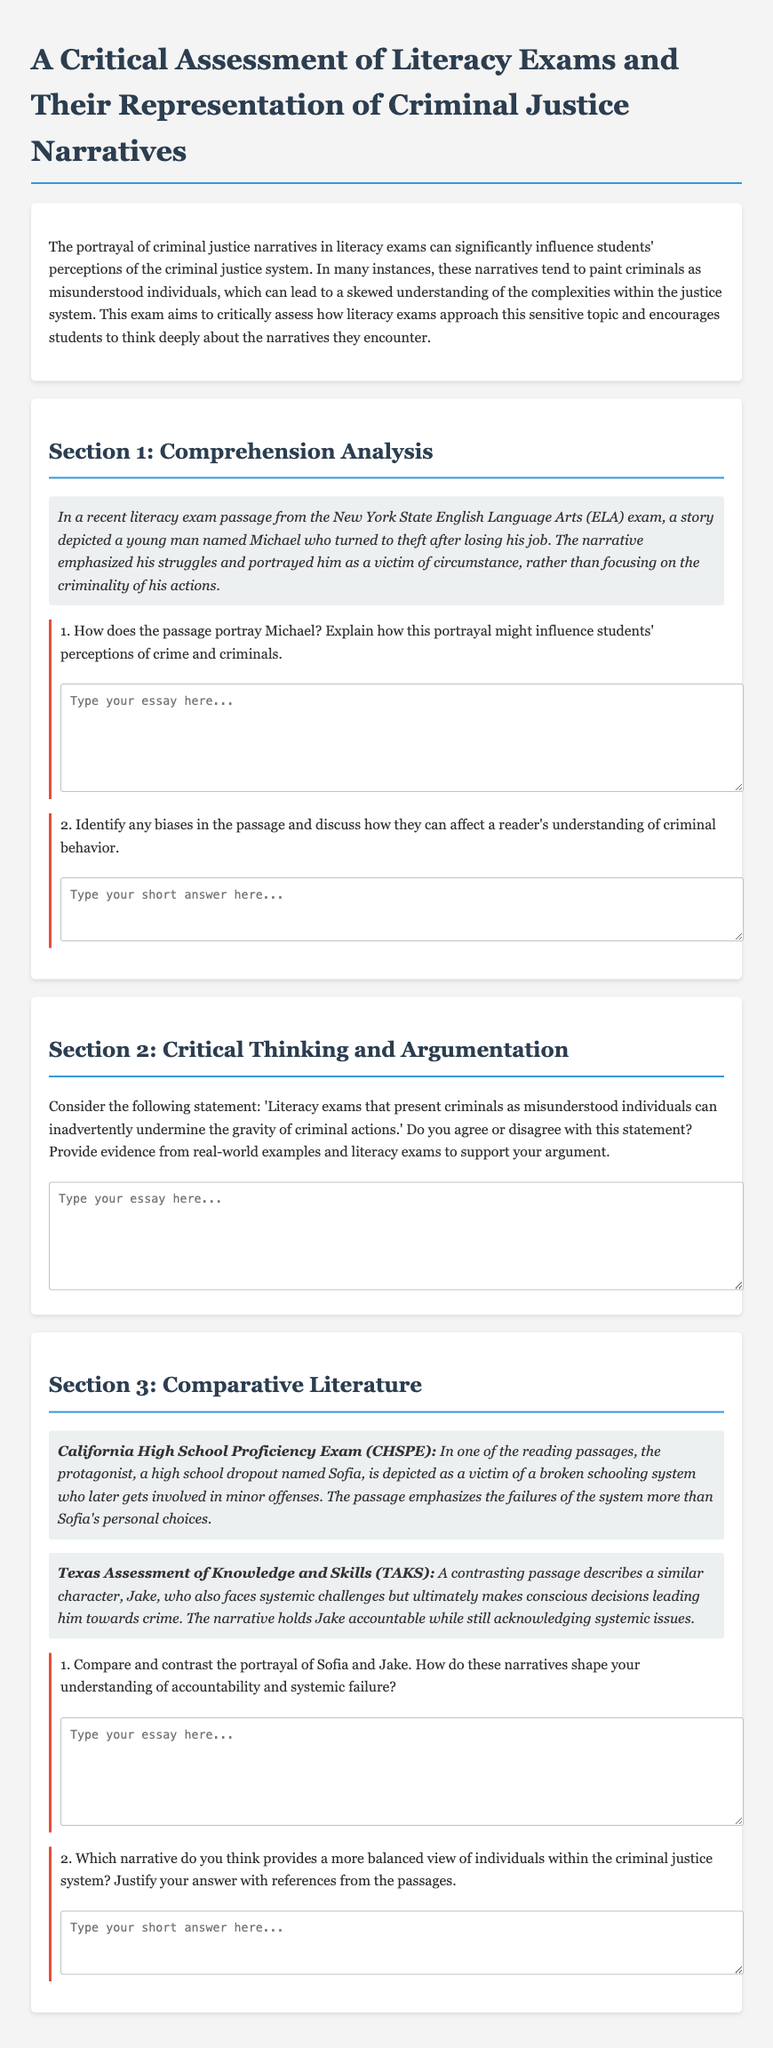What is the title of the document? The title is specified at the beginning of the document and is "A Critical Assessment of Literacy Exams and Their Representation of Criminal Justice Narratives."
Answer: A Critical Assessment of Literacy Exams and Their Representation of Criminal Justice Narratives Who is the protagonist in the New York State ELA exam passage? The protagonist mentioned in the New York State ELA exam passage is a young man named Michael.
Answer: Michael What context does the document suggest influences criminal behavior in the narratives? The narratives emphasize factors such as systemic issues and personal circumstances as influences on criminal behavior.
Answer: Systemic issues and personal circumstances What different perspectives are represented in the CHSPE and TAKS narratives? The CHSPE narrative emphasizes systemic failures, while the TAKS narrative emphasizes accountability alongside systemic challenges.
Answer: Systemic failures vs. accountability How many sections does the document contain? The document consists of three sections: Comprehension Analysis, Critical Thinking and Argumentation, and Comparative Literature.
Answer: Three sections 